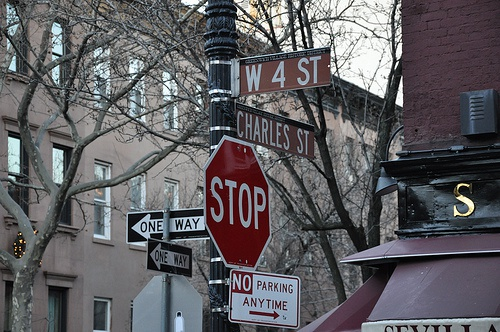Describe the objects in this image and their specific colors. I can see a stop sign in gray, maroon, and darkgray tones in this image. 